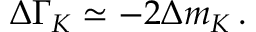<formula> <loc_0><loc_0><loc_500><loc_500>\Delta \Gamma _ { K } \simeq - 2 \Delta m _ { K } \, .</formula> 